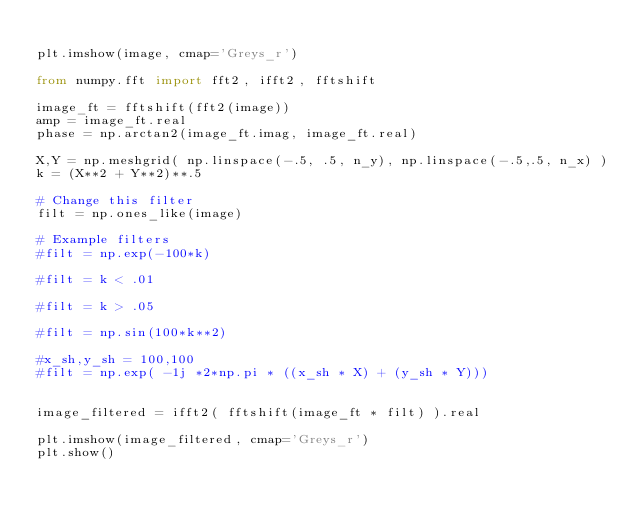<code> <loc_0><loc_0><loc_500><loc_500><_Python_>
plt.imshow(image, cmap='Greys_r')

from numpy.fft import fft2, ifft2, fftshift

image_ft = fftshift(fft2(image))
amp = image_ft.real
phase = np.arctan2(image_ft.imag, image_ft.real)

X,Y = np.meshgrid( np.linspace(-.5, .5, n_y), np.linspace(-.5,.5, n_x) )
k = (X**2 + Y**2)**.5

# Change this filter
filt = np.ones_like(image)

# Example filters
#filt = np.exp(-100*k)

#filt = k < .01

#filt = k > .05

#filt = np.sin(100*k**2)

#x_sh,y_sh = 100,100
#filt = np.exp( -1j *2*np.pi * ((x_sh * X) + (y_sh * Y)))


image_filtered = ifft2( fftshift(image_ft * filt) ).real

plt.imshow(image_filtered, cmap='Greys_r')
plt.show()

</code> 